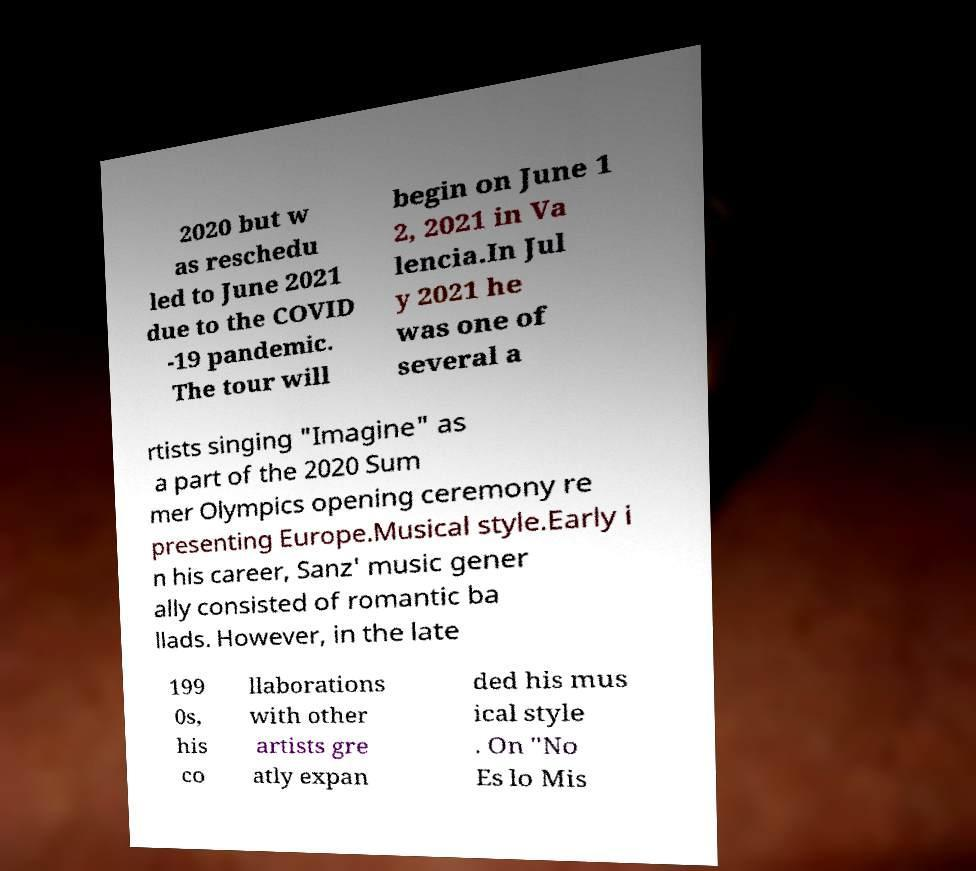Could you extract and type out the text from this image? 2020 but w as reschedu led to June 2021 due to the COVID -19 pandemic. The tour will begin on June 1 2, 2021 in Va lencia.In Jul y 2021 he was one of several a rtists singing "Imagine" as a part of the 2020 Sum mer Olympics opening ceremony re presenting Europe.Musical style.Early i n his career, Sanz' music gener ally consisted of romantic ba llads. However, in the late 199 0s, his co llaborations with other artists gre atly expan ded his mus ical style . On "No Es lo Mis 